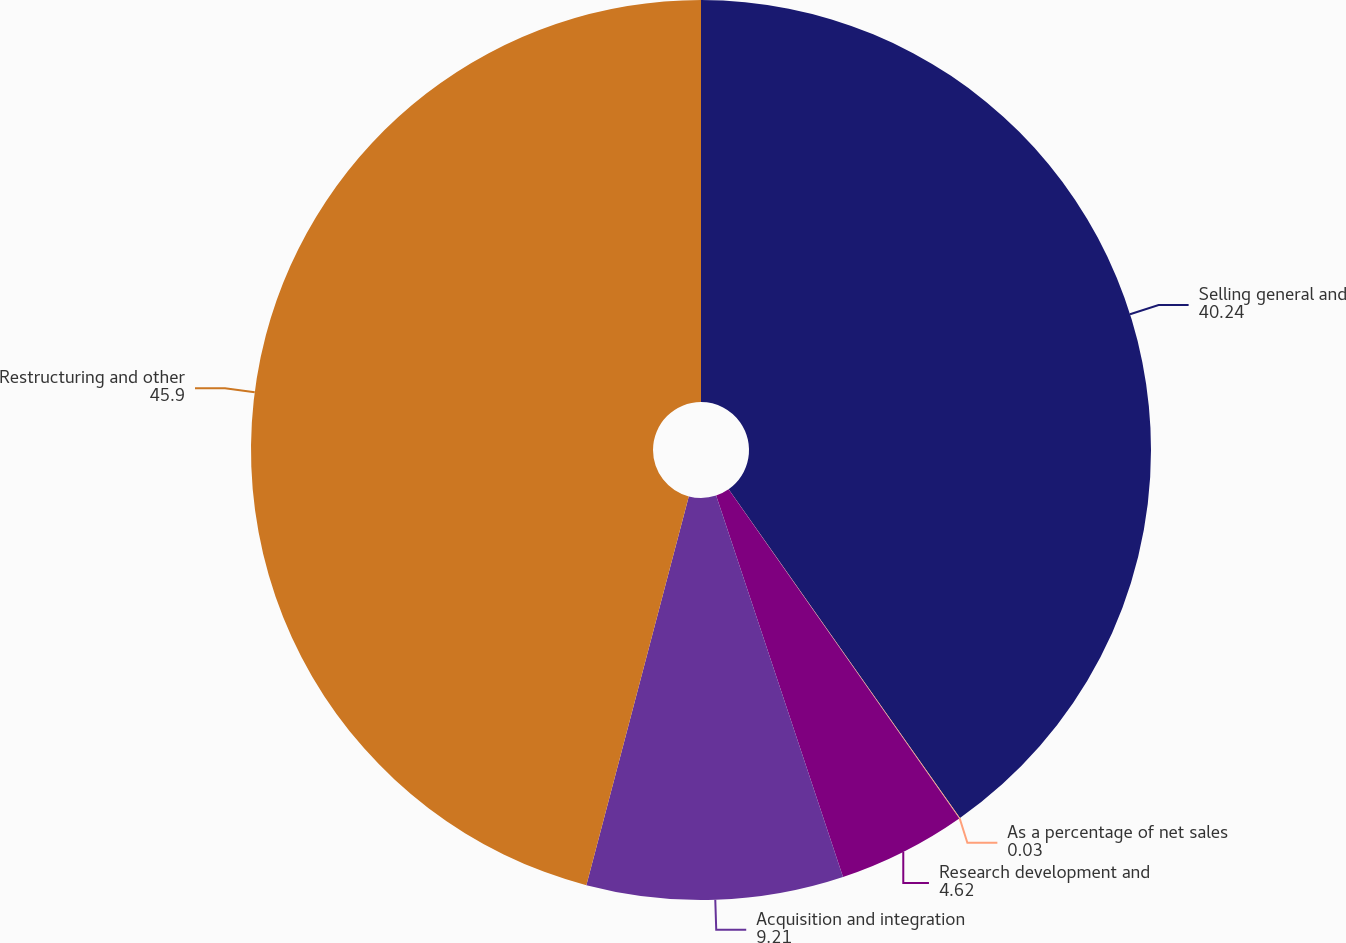Convert chart. <chart><loc_0><loc_0><loc_500><loc_500><pie_chart><fcel>Selling general and<fcel>As a percentage of net sales<fcel>Research development and<fcel>Acquisition and integration<fcel>Restructuring and other<nl><fcel>40.24%<fcel>0.03%<fcel>4.62%<fcel>9.21%<fcel>45.9%<nl></chart> 